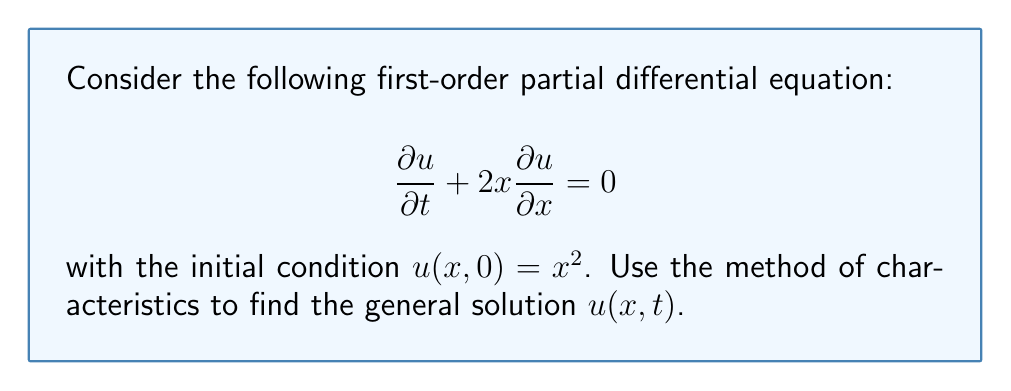Provide a solution to this math problem. To solve this problem using the method of characteristics, we follow these steps:

1) First, we write the characteristic equations:

   $$ \frac{dt}{ds} = 1, \quad \frac{dx}{ds} = 2x, \quad \frac{du}{ds} = 0 $$

2) Solve the first characteristic equation:
   $$ \frac{dt}{ds} = 1 \implies t = s + c_1 $$
   We can choose $c_1 = 0$, so $t = s$.

3) Solve the second characteristic equation:
   $$ \frac{dx}{ds} = 2x $$
   This is a separable ODE. Solving it:
   $$ \int \frac{dx}{x} = \int 2ds $$
   $$ \ln|x| = 2s + c_2 $$
   $$ x = Ce^{2s} $$
   where $C = e^{c_2}$ is a constant.

4) The third equation tells us that $u$ is constant along characteristics:
   $$ \frac{du}{ds} = 0 \implies u = \text{constant} $$

5) Now, we need to express the initial condition in terms of the characteristic variables:
   At $t = 0$, $s = 0$, so $x = C$.
   The initial condition becomes: $u = C^2$

6) The general solution is thus:
   $$ u = (xe^{-2t})^2 $$

   This satisfies the initial condition and is constant along characteristics.

7) To verify, we can substitute this solution back into the original PDE:

   $$ \frac{\partial u}{\partial t} = -4x^2e^{-4t} $$
   $$ \frac{\partial u}{\partial x} = 2xe^{-4t} $$

   Substituting into the PDE:
   $$ -4x^2e^{-4t} + 2x(2xe^{-4t}) = 0 $$

   Which verifies that our solution satisfies the PDE.
Answer: The general solution to the given PDE is:

$$ u(x,t) = (xe^{-2t})^2 $$ 